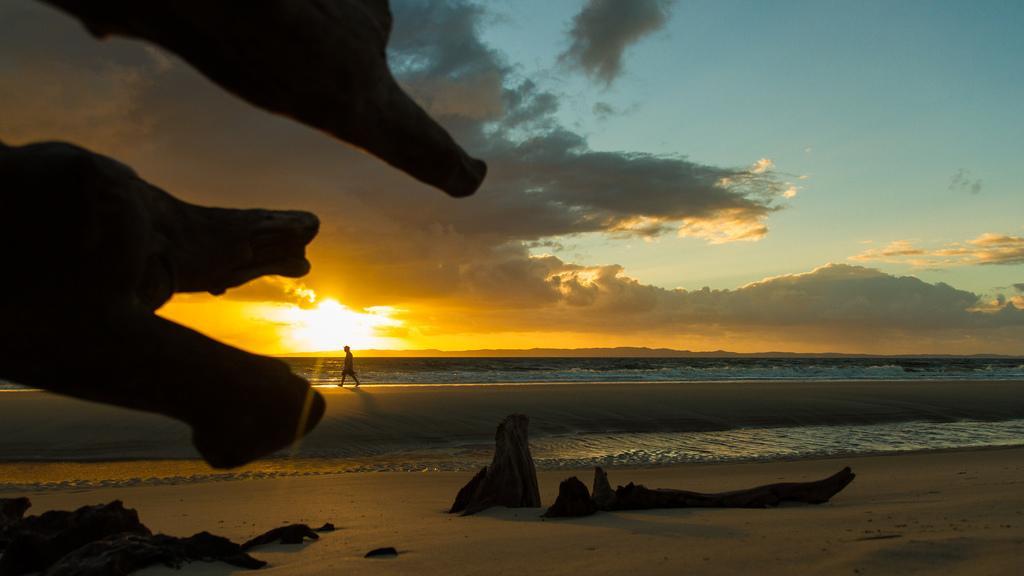In one or two sentences, can you explain what this image depicts? In this picture I can observe driftwood in the middle of the picture. On the left side I can observe a person. In the background there is an ocean and some clouds in the sky. 